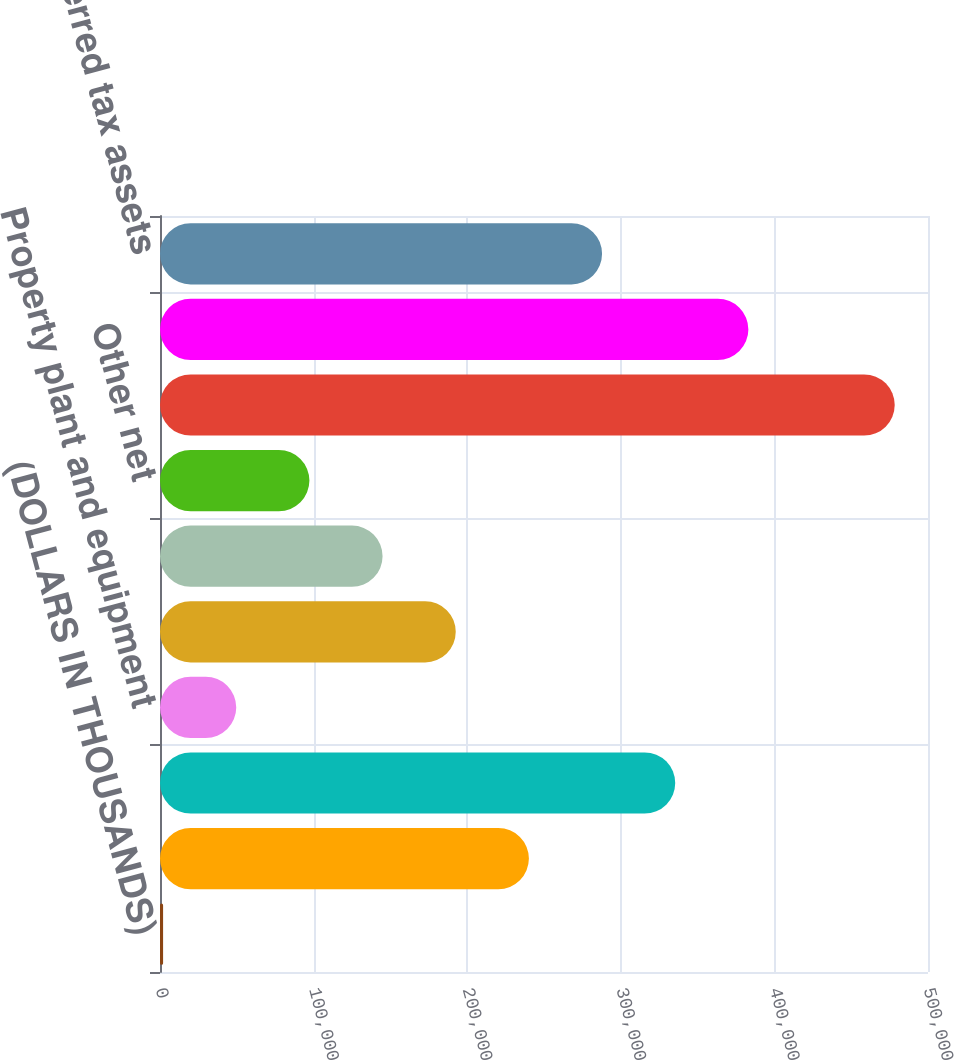Convert chart to OTSL. <chart><loc_0><loc_0><loc_500><loc_500><bar_chart><fcel>(DOLLARS IN THOUSANDS)<fcel>Employee and retiree benefits<fcel>Credit and net operating loss<fcel>Property plant and equipment<fcel>Trademarks and other (1)<fcel>Amortizable R&D expenses<fcel>Other net<fcel>Gross deferred tax assets<fcel>Valuation allowance (1)<fcel>Total net deferred tax assets<nl><fcel>2011<fcel>240166<fcel>335429<fcel>49642.1<fcel>192535<fcel>144904<fcel>97273.2<fcel>478322<fcel>383060<fcel>287798<nl></chart> 